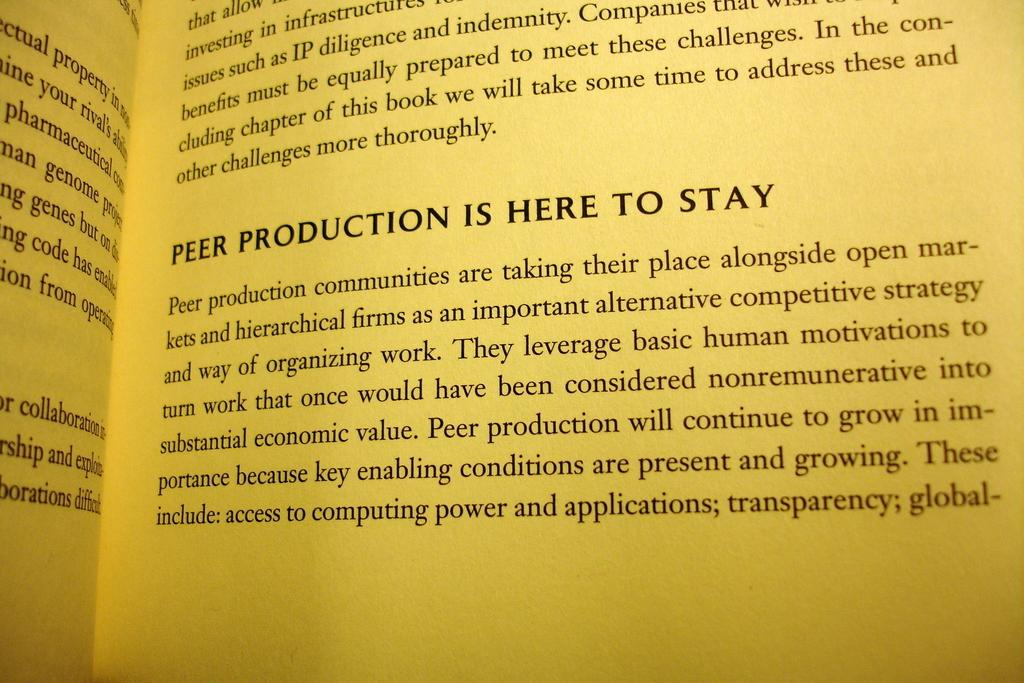<image>
Present a compact description of the photo's key features. An open book includes a section about peer production. 